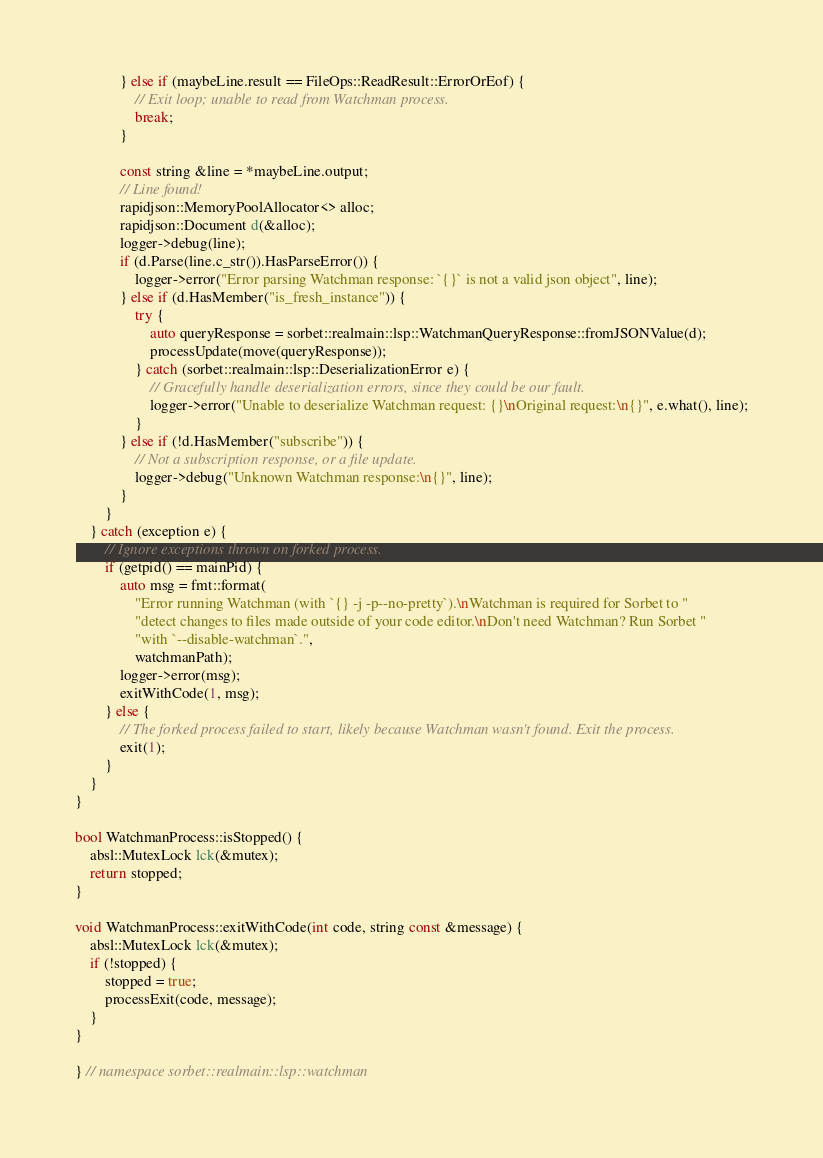Convert code to text. <code><loc_0><loc_0><loc_500><loc_500><_C++_>            } else if (maybeLine.result == FileOps::ReadResult::ErrorOrEof) {
                // Exit loop; unable to read from Watchman process.
                break;
            }

            const string &line = *maybeLine.output;
            // Line found!
            rapidjson::MemoryPoolAllocator<> alloc;
            rapidjson::Document d(&alloc);
            logger->debug(line);
            if (d.Parse(line.c_str()).HasParseError()) {
                logger->error("Error parsing Watchman response: `{}` is not a valid json object", line);
            } else if (d.HasMember("is_fresh_instance")) {
                try {
                    auto queryResponse = sorbet::realmain::lsp::WatchmanQueryResponse::fromJSONValue(d);
                    processUpdate(move(queryResponse));
                } catch (sorbet::realmain::lsp::DeserializationError e) {
                    // Gracefully handle deserialization errors, since they could be our fault.
                    logger->error("Unable to deserialize Watchman request: {}\nOriginal request:\n{}", e.what(), line);
                }
            } else if (!d.HasMember("subscribe")) {
                // Not a subscription response, or a file update.
                logger->debug("Unknown Watchman response:\n{}", line);
            }
        }
    } catch (exception e) {
        // Ignore exceptions thrown on forked process.
        if (getpid() == mainPid) {
            auto msg = fmt::format(
                "Error running Watchman (with `{} -j -p--no-pretty`).\nWatchman is required for Sorbet to "
                "detect changes to files made outside of your code editor.\nDon't need Watchman? Run Sorbet "
                "with `--disable-watchman`.",
                watchmanPath);
            logger->error(msg);
            exitWithCode(1, msg);
        } else {
            // The forked process failed to start, likely because Watchman wasn't found. Exit the process.
            exit(1);
        }
    }
}

bool WatchmanProcess::isStopped() {
    absl::MutexLock lck(&mutex);
    return stopped;
}

void WatchmanProcess::exitWithCode(int code, string const &message) {
    absl::MutexLock lck(&mutex);
    if (!stopped) {
        stopped = true;
        processExit(code, message);
    }
}

} // namespace sorbet::realmain::lsp::watchman
</code> 